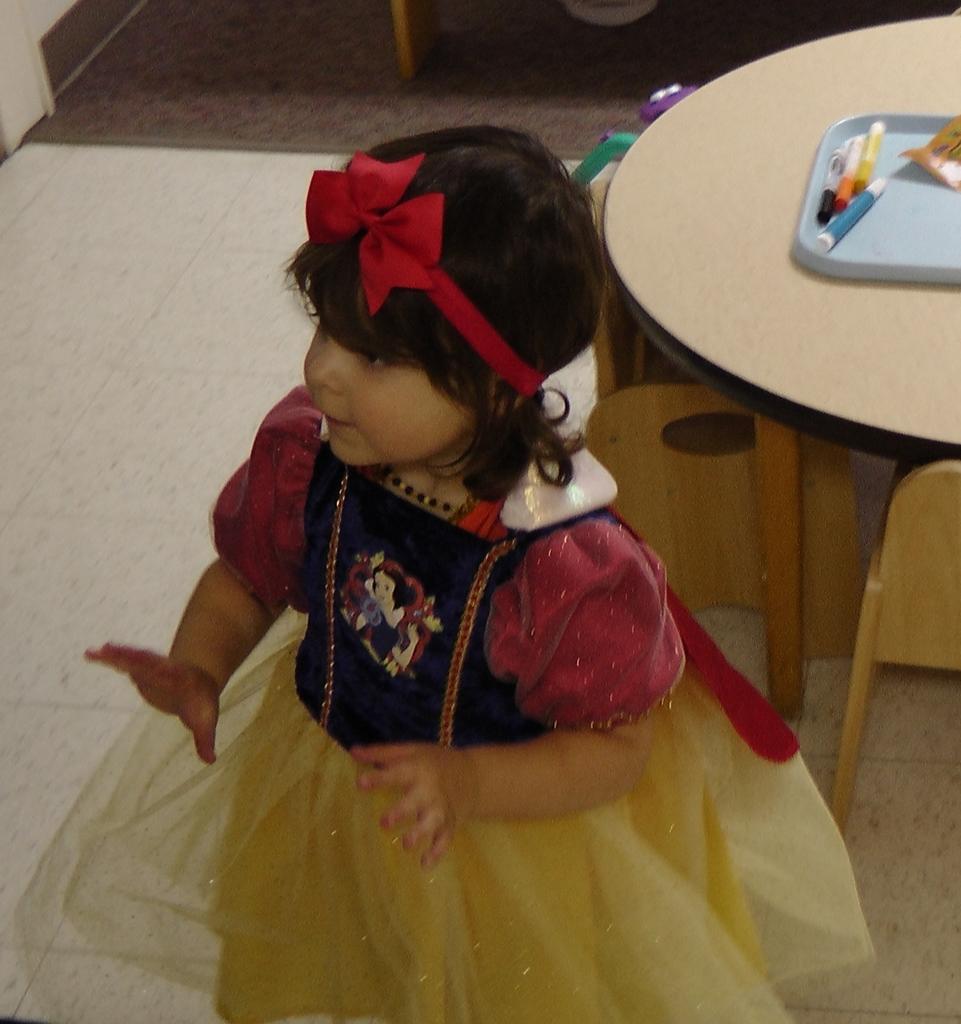How would you summarize this image in a sentence or two? There is a girl wearing a gown standing on the floor. She is wearing a red color headband. Behind her there is a table. On the table, there are some accessories. 